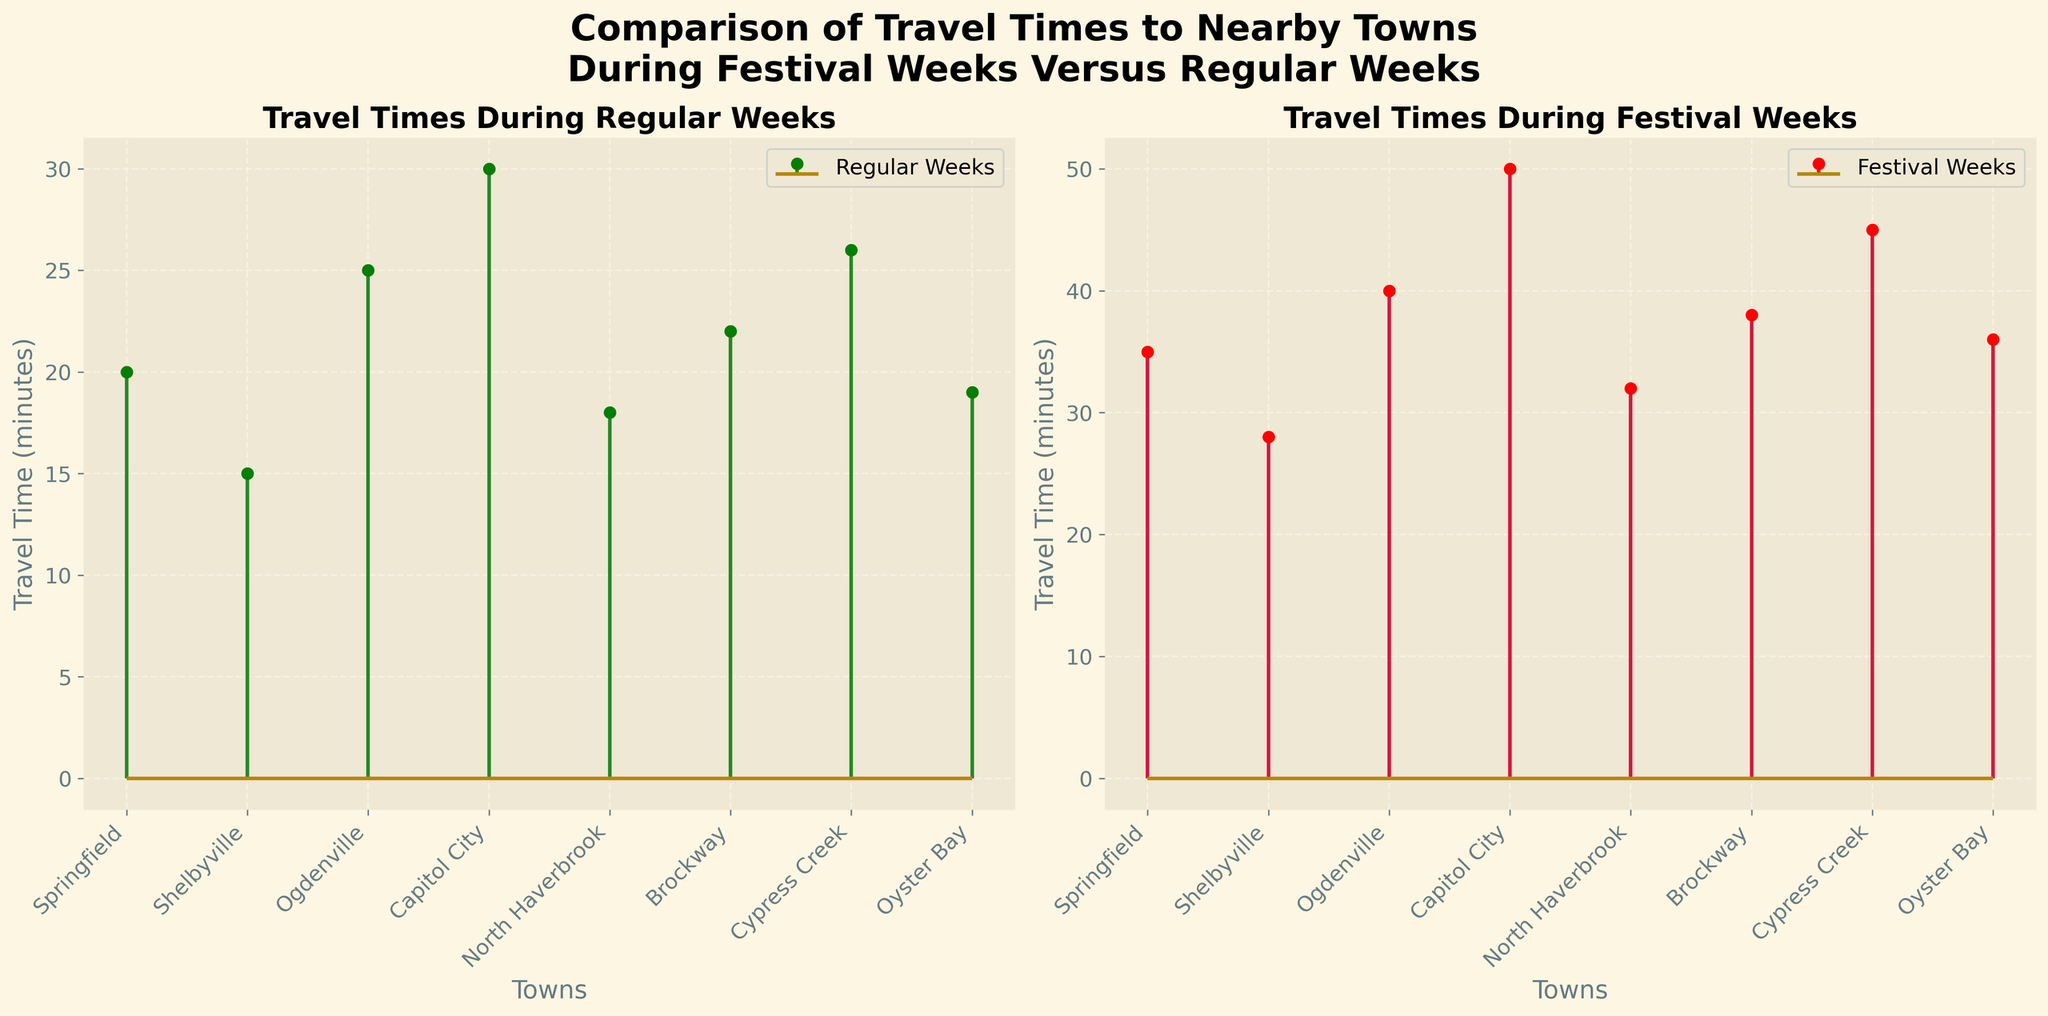Which town has the longest travel time during festival weeks? According to the right subplot that represents travel times during festival weeks, Capitol City has the longest travel time with 50 minutes.
Answer: Capitol City What's the difference in travel time to Springfield between regular weeks and festival weeks? By comparing the travel times in the left and right subplots for Springfield, the travel time during regular weeks is 20 minutes while during festival weeks it is 35 minutes. The difference is 35 - 20 = 15 minutes.
Answer: 15 minutes Which town sees the least increase in travel time during festival weeks compared to regular weeks? By calculating the difference for each town, Shelbyville has an increase from 15 to 28 minutes, which is 13 minutes, the smallest increase among all towns.
Answer: Shelbyville In regular weeks, which town has the fastest travel time? In the left subplot that represents travel times during regular weeks, Shelbyville has the fastest travel time at 15 minutes.
Answer: Shelbyville Compare travel times during festival weeks between Ogdenville and Brockway. Which town has a shorter travel time? Looking at the travel times in the right subplot, Ogdenville has a travel time of 40 minutes, while Brockway has a travel time of 38 minutes. Therefore, Brockway has a shorter travel time.
Answer: Brockway How much does the travel time to North Haverbrook increase from regular to festival weeks in percentage? The travel time to North Haverbrook is 18 minutes during regular weeks and 32 minutes during festival weeks. The increase is (32 - 18) = 14 minutes. The percentage increase is (14 / 18) * 100 ≈ 77.78%.
Answer: 77.78% Which town has a greater travel time during regular weeks: Oyster Bay or Capitol City? Comparing travel times in the left subplot, Oyster Bay has a travel time of 19 minutes and Capitol City has a travel time of 30 minutes. Hence, Capitol City has a greater travel time.
Answer: Capitol City What is the average travel time to Springfield, Shelbyville, and Cypress Creek during festival weeks? The travel times during festival weeks for Springfield, Shelbyville, and Cypress Creek are 35, 28, and 45 minutes respectively. The average is (35 + 28 + 45) / 3 = 36 minutes.
Answer: 36 minutes What is the average difference in travel time between regular and festival weeks for all towns? The differences for each town are: Springfield (35-20=15), Shelbyville (28-15=13), Ogdenville (40-25=15), Capitol City (50-30=20), North Haverbrook (32-18=14), Brockway (38-22=16), Cypress Creek (45-26=19), Oyster Bay (36-19=17). The average difference is (15+13+15+20+14+16+19+17) / 8 ≈ 16.125 minutes.
Answer: 16.125 minutes 